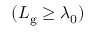<formula> <loc_0><loc_0><loc_500><loc_500>( L _ { g } \geq \lambda _ { 0 } )</formula> 